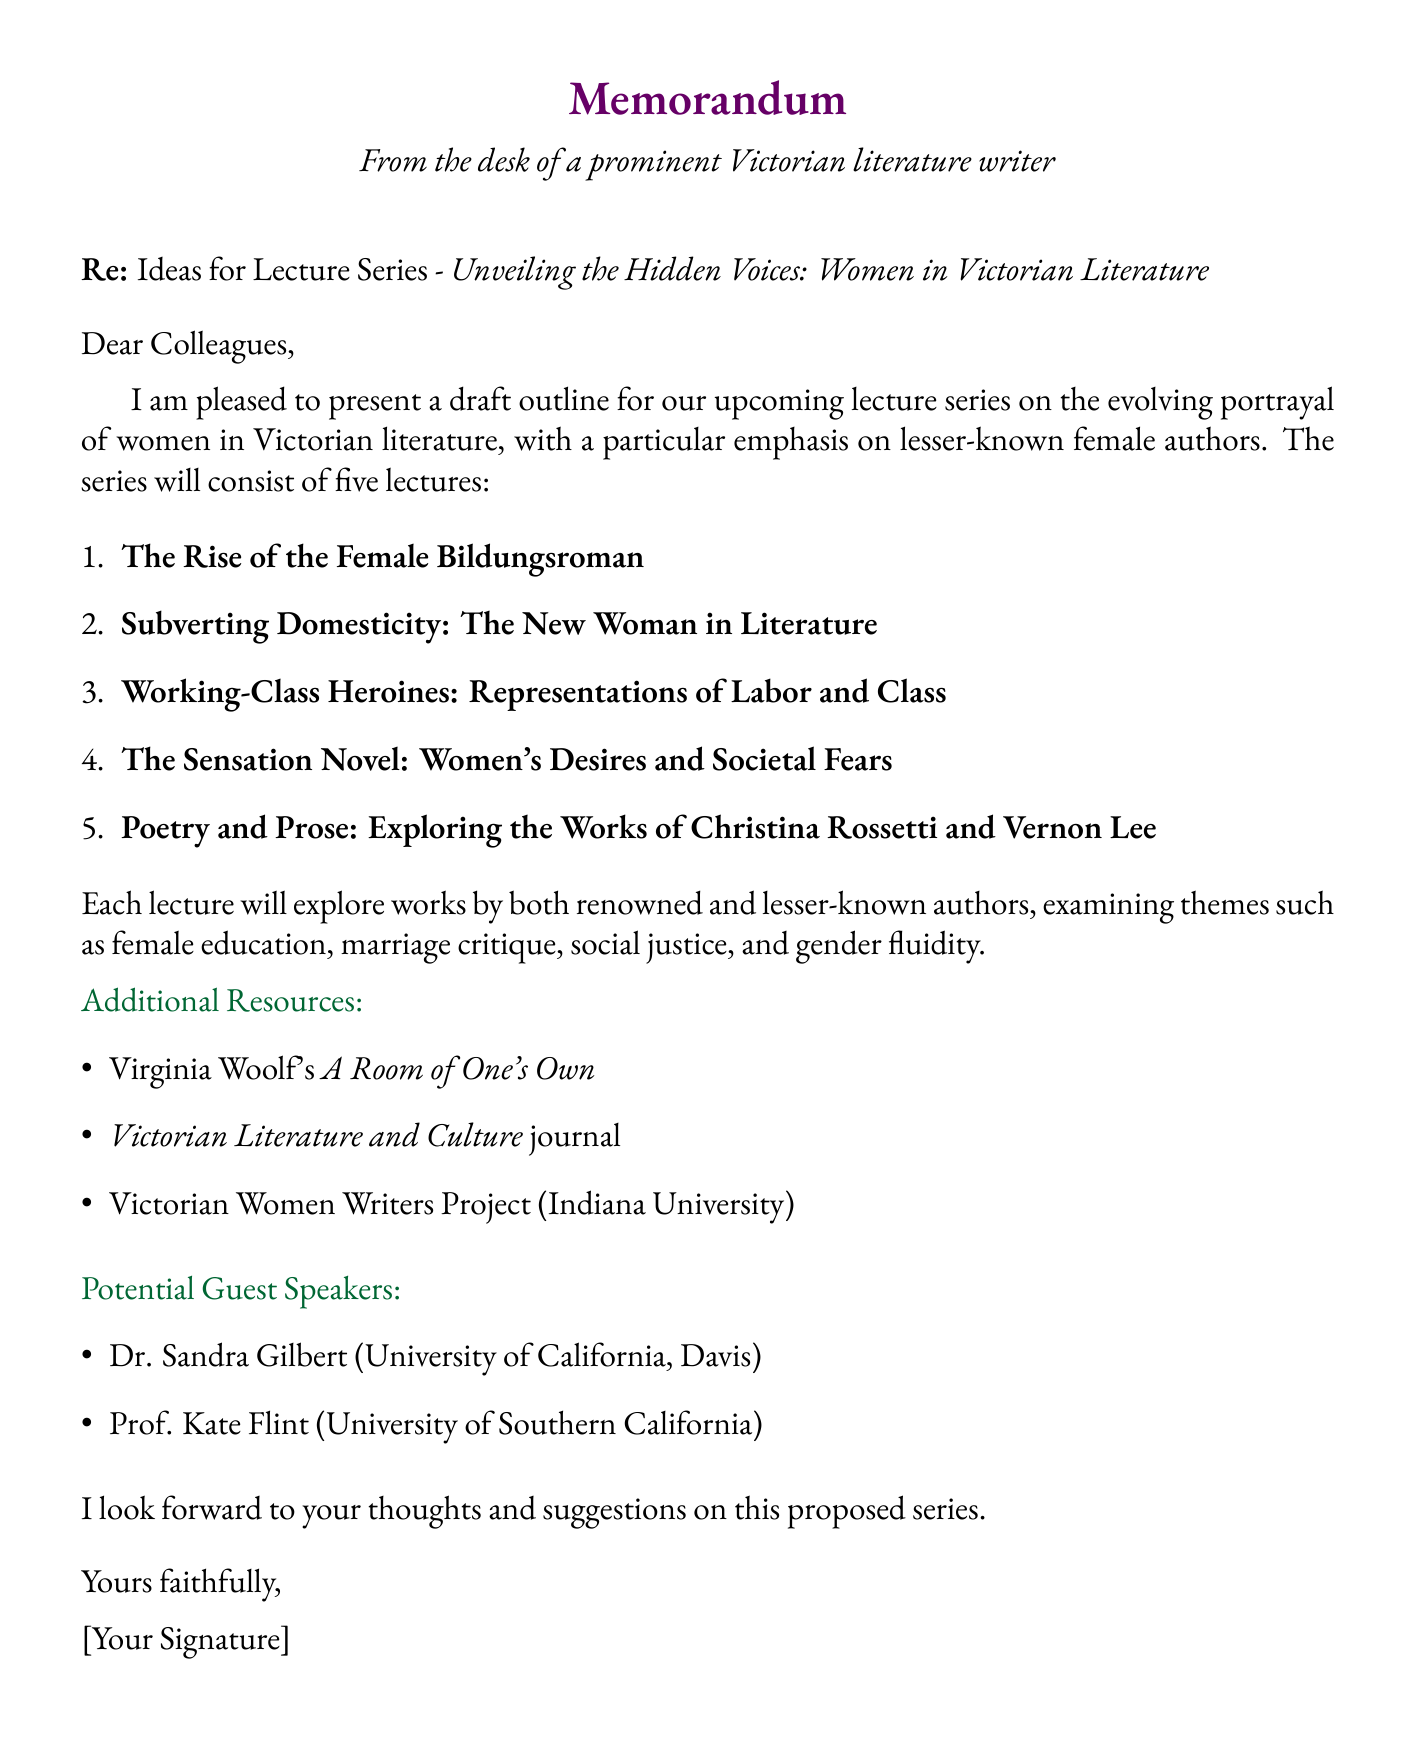what is the title of the lecture series? The title is listed at the beginning of the document, indicating the focus of the series.
Answer: Unveiling the Hidden Voices: Women in Victorian Literature how many lectures are included in the series? The document enumerates the five lectures that will be part of the series.
Answer: five name one author discussed in "The Rise of the Female Bildungsroman" lecture. This information can be retrieved from the list of authors associated with that lecture.
Answer: Charlotte Brontë which theme is associated with the lecture "Subverting Domesticity: The New Woman in Literature"? The document lists the themes associated with each lecture, indicating areas of focus.
Answer: Marriage critique who is a potential guest speaker from the University of Southern California? The document specifically lists potential guest speakers along with their affiliations.
Answer: Prof. Kate Flint what type of resource is "Victorian Literature and Culture"? The document describes the different types of additional resources available for further exploration of the topic.
Answer: Academic journal which work of literature is associated with Frances Trollope? The document lists key works for each lecture, indicating notable texts by the authors discussed.
Answer: Michael Armstrong, the Factory Boy what is one theme of "The Sensation Novel"? The document specifies the themes related to the lectures, allowing for specific associations.
Answer: Female sexuality name one key work by Christina Rossetti. The work is included in the list of key works for the lecture on Rossetti and Vernon Lee.
Answer: Goblin Market 